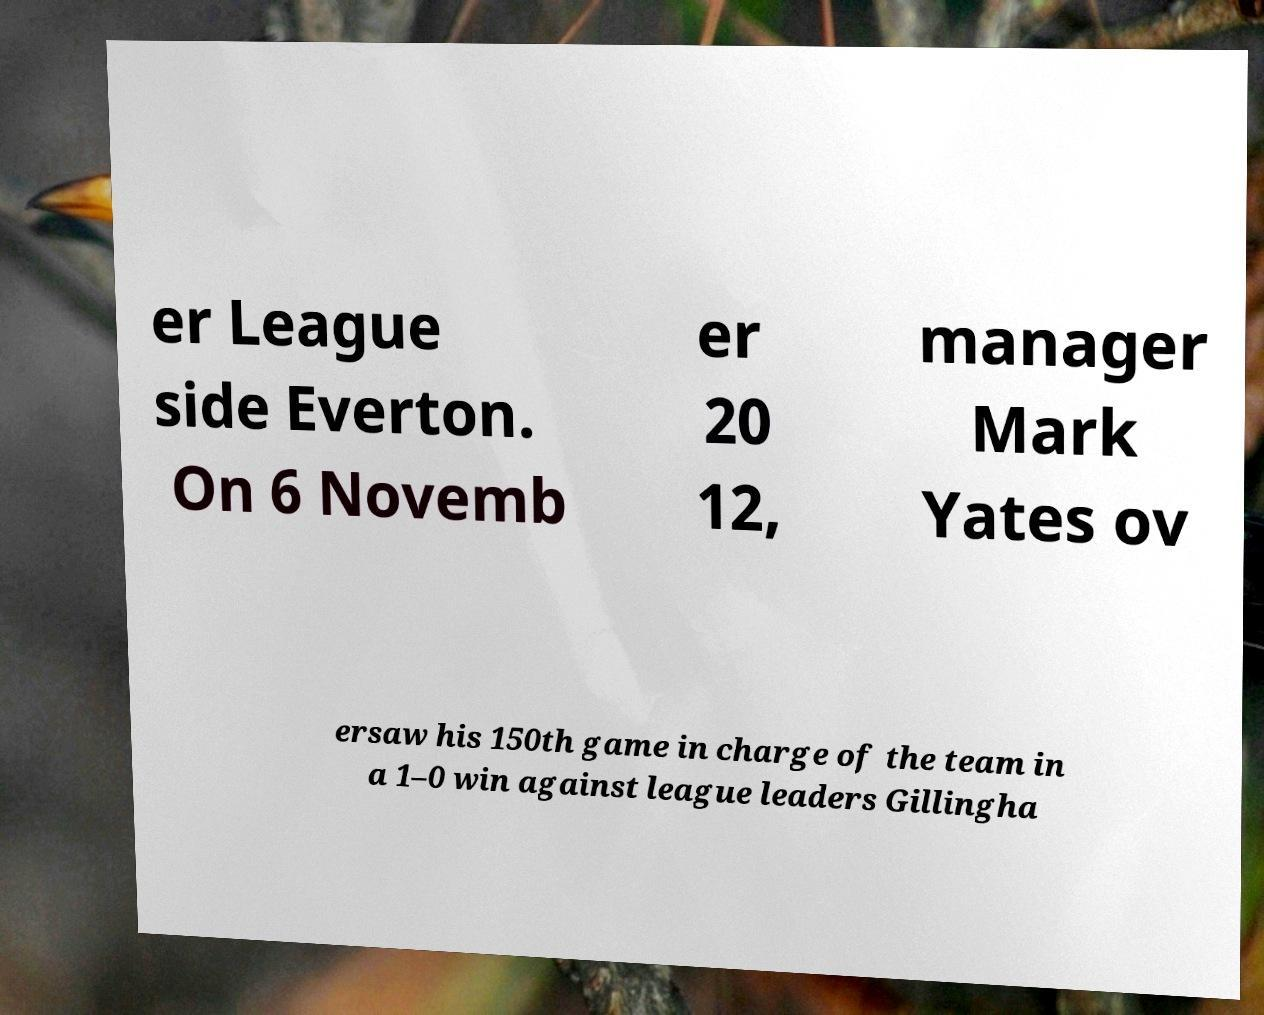Could you assist in decoding the text presented in this image and type it out clearly? er League side Everton. On 6 Novemb er 20 12, manager Mark Yates ov ersaw his 150th game in charge of the team in a 1–0 win against league leaders Gillingha 